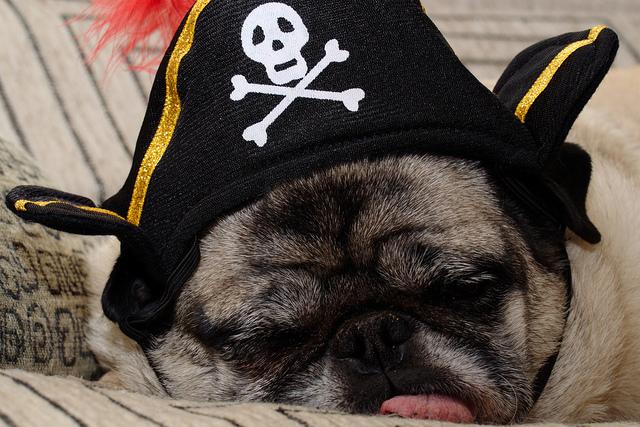What color is the feather on the hat?
Quick response, please. Red. Is the dog's fur shiny?
Short answer required. No. Is this dog content?
Short answer required. Yes. Why is the dog wearing this hat?
Give a very brief answer. Halloween. Would anyone think that this dog is a terror of the high seas?
Write a very short answer. No. What is the symbol on the hat?
Short answer required. Skull and crossbones. Does the dog like being outside?
Short answer required. No. 